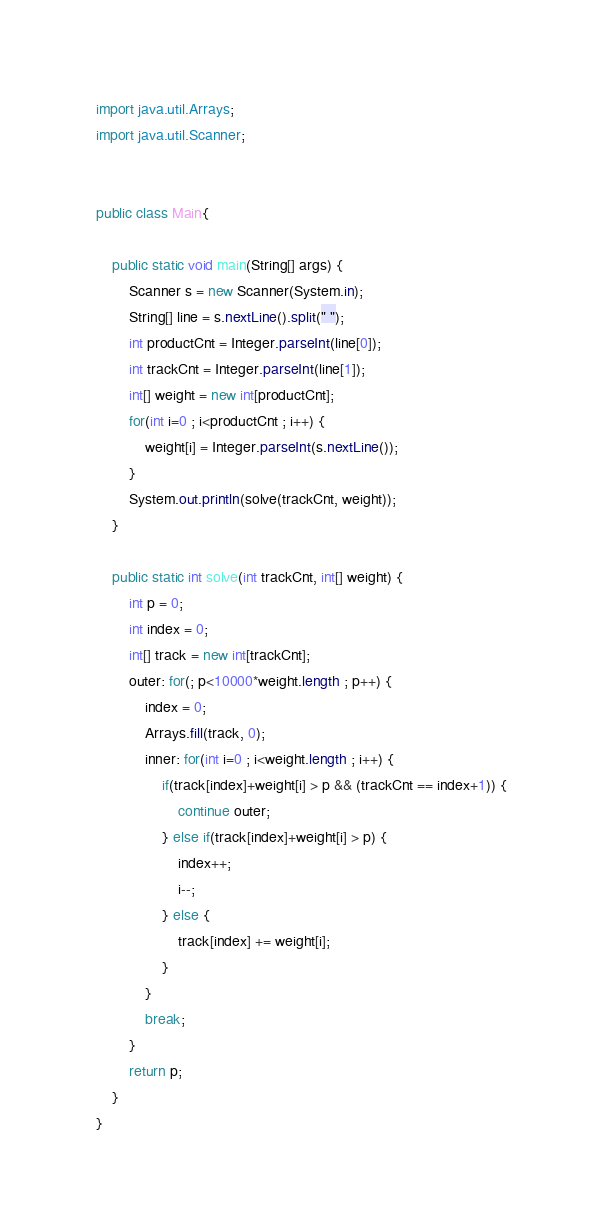<code> <loc_0><loc_0><loc_500><loc_500><_Java_>import java.util.Arrays;
import java.util.Scanner;


public class Main{

	public static void main(String[] args) {
		Scanner s = new Scanner(System.in);
		String[] line = s.nextLine().split(" ");
		int productCnt = Integer.parseInt(line[0]);
		int trackCnt = Integer.parseInt(line[1]);
		int[] weight = new int[productCnt];
		for(int i=0 ; i<productCnt ; i++) {
			weight[i] = Integer.parseInt(s.nextLine());
		}
		System.out.println(solve(trackCnt, weight));
	}

	public static int solve(int trackCnt, int[] weight) {
		int p = 0;
		int index = 0;
		int[] track = new int[trackCnt];
		outer: for(; p<10000*weight.length ; p++) {
			index = 0;
			Arrays.fill(track, 0);
			inner: for(int i=0 ; i<weight.length ; i++) {
				if(track[index]+weight[i] > p && (trackCnt == index+1)) {
					continue outer;
				} else if(track[index]+weight[i] > p) {
					index++;
					i--;
				} else {
					track[index] += weight[i];
				}
			}
			break;
		}
		return p;
	}
}</code> 